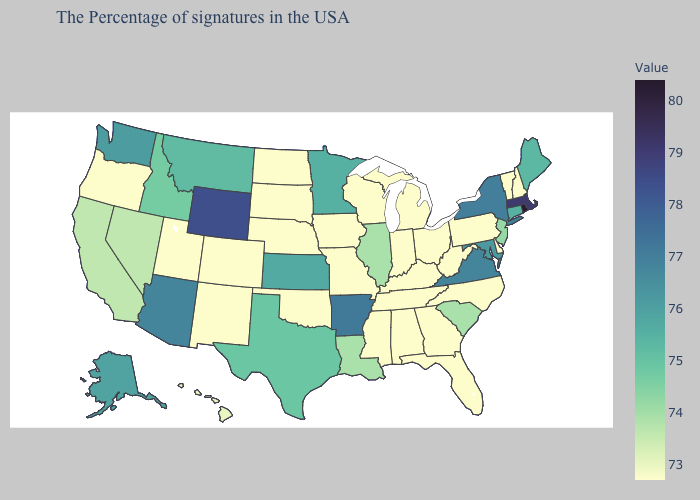Does Rhode Island have the lowest value in the Northeast?
Short answer required. No. Among the states that border California , which have the lowest value?
Be succinct. Oregon. Does New York have the highest value in the Northeast?
Keep it brief. No. Does New Mexico have the highest value in the USA?
Short answer required. No. Is the legend a continuous bar?
Give a very brief answer. Yes. Does Nevada have the highest value in the West?
Answer briefly. No. Does the map have missing data?
Short answer required. No. 